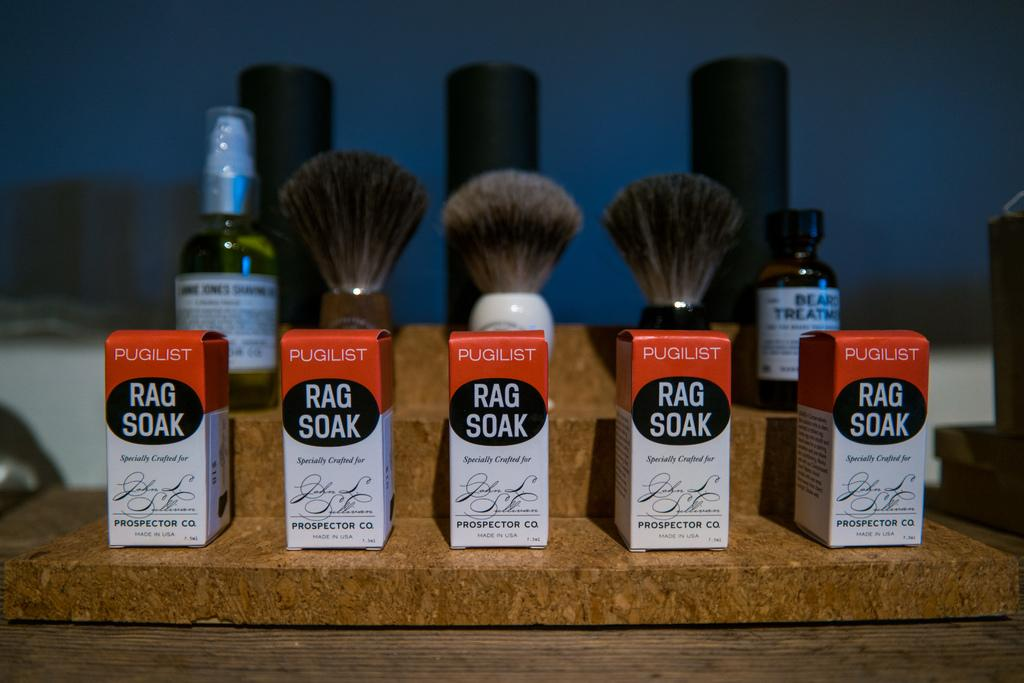<image>
Render a clear and concise summary of the photo. Brushes and toiletry items in front of small boxes that read Rag Soak. 